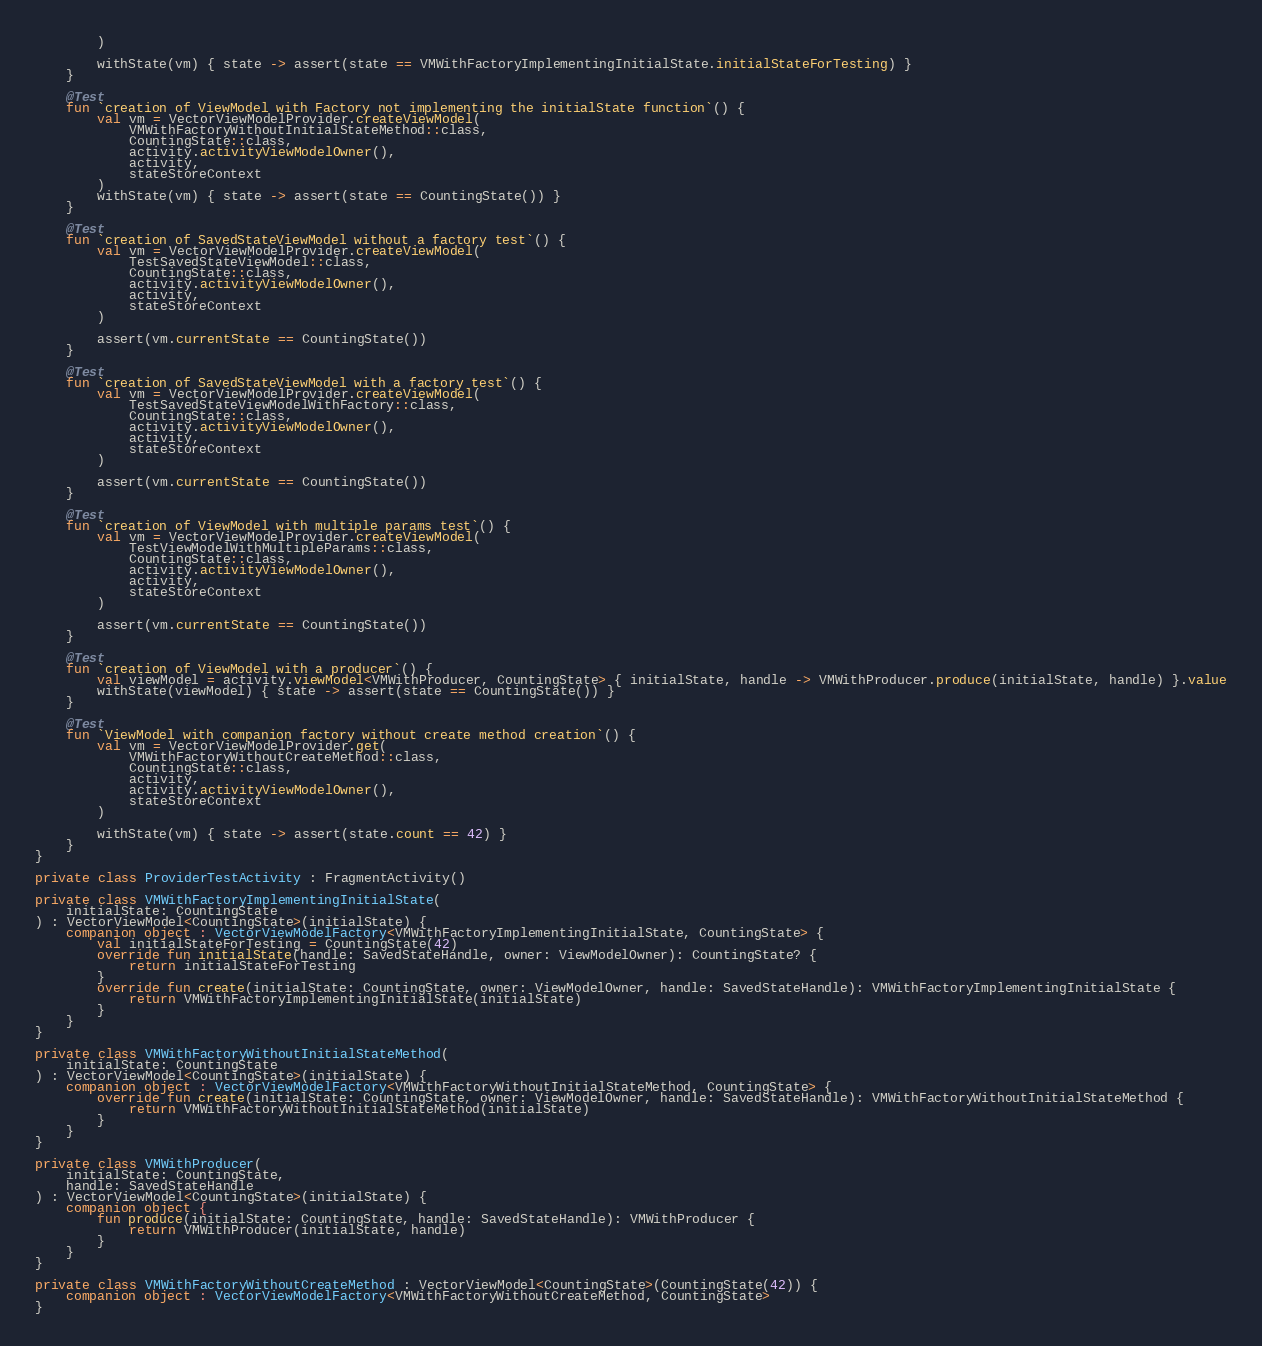<code> <loc_0><loc_0><loc_500><loc_500><_Kotlin_>        )

        withState(vm) { state -> assert(state == VMWithFactoryImplementingInitialState.initialStateForTesting) }
    }

    @Test
    fun `creation of ViewModel with Factory not implementing the initialState function`() {
        val vm = VectorViewModelProvider.createViewModel(
            VMWithFactoryWithoutInitialStateMethod::class,
            CountingState::class,
            activity.activityViewModelOwner(),
            activity,
            stateStoreContext
        )
        withState(vm) { state -> assert(state == CountingState()) }
    }

    @Test
    fun `creation of SavedStateViewModel without a factory test`() {
        val vm = VectorViewModelProvider.createViewModel(
            TestSavedStateViewModel::class,
            CountingState::class,
            activity.activityViewModelOwner(),
            activity,
            stateStoreContext
        )

        assert(vm.currentState == CountingState())
    }

    @Test
    fun `creation of SavedStateViewModel with a factory test`() {
        val vm = VectorViewModelProvider.createViewModel(
            TestSavedStateViewModelWithFactory::class,
            CountingState::class,
            activity.activityViewModelOwner(),
            activity,
            stateStoreContext
        )

        assert(vm.currentState == CountingState())
    }

    @Test
    fun `creation of ViewModel with multiple params test`() {
        val vm = VectorViewModelProvider.createViewModel(
            TestViewModelWithMultipleParams::class,
            CountingState::class,
            activity.activityViewModelOwner(),
            activity,
            stateStoreContext
        )

        assert(vm.currentState == CountingState())
    }

    @Test
    fun `creation of ViewModel with a producer`() {
        val viewModel = activity.viewModel<VMWithProducer, CountingState> { initialState, handle -> VMWithProducer.produce(initialState, handle) }.value
        withState(viewModel) { state -> assert(state == CountingState()) }
    }

    @Test
    fun `ViewModel with companion factory without create method creation`() {
        val vm = VectorViewModelProvider.get(
            VMWithFactoryWithoutCreateMethod::class,
            CountingState::class,
            activity,
            activity.activityViewModelOwner(),
            stateStoreContext
        )

        withState(vm) { state -> assert(state.count == 42) }
    }
}

private class ProviderTestActivity : FragmentActivity()

private class VMWithFactoryImplementingInitialState(
    initialState: CountingState
) : VectorViewModel<CountingState>(initialState) {
    companion object : VectorViewModelFactory<VMWithFactoryImplementingInitialState, CountingState> {
        val initialStateForTesting = CountingState(42)
        override fun initialState(handle: SavedStateHandle, owner: ViewModelOwner): CountingState? {
            return initialStateForTesting
        }
        override fun create(initialState: CountingState, owner: ViewModelOwner, handle: SavedStateHandle): VMWithFactoryImplementingInitialState {
            return VMWithFactoryImplementingInitialState(initialState)
        }
    }
}

private class VMWithFactoryWithoutInitialStateMethod(
    initialState: CountingState
) : VectorViewModel<CountingState>(initialState) {
    companion object : VectorViewModelFactory<VMWithFactoryWithoutInitialStateMethod, CountingState> {
        override fun create(initialState: CountingState, owner: ViewModelOwner, handle: SavedStateHandle): VMWithFactoryWithoutInitialStateMethod {
            return VMWithFactoryWithoutInitialStateMethod(initialState)
        }
    }
}

private class VMWithProducer(
    initialState: CountingState,
    handle: SavedStateHandle
) : VectorViewModel<CountingState>(initialState) {
    companion object {
        fun produce(initialState: CountingState, handle: SavedStateHandle): VMWithProducer {
            return VMWithProducer(initialState, handle)
        }
    }
}

private class VMWithFactoryWithoutCreateMethod : VectorViewModel<CountingState>(CountingState(42)) {
    companion object : VectorViewModelFactory<VMWithFactoryWithoutCreateMethod, CountingState>
}</code> 